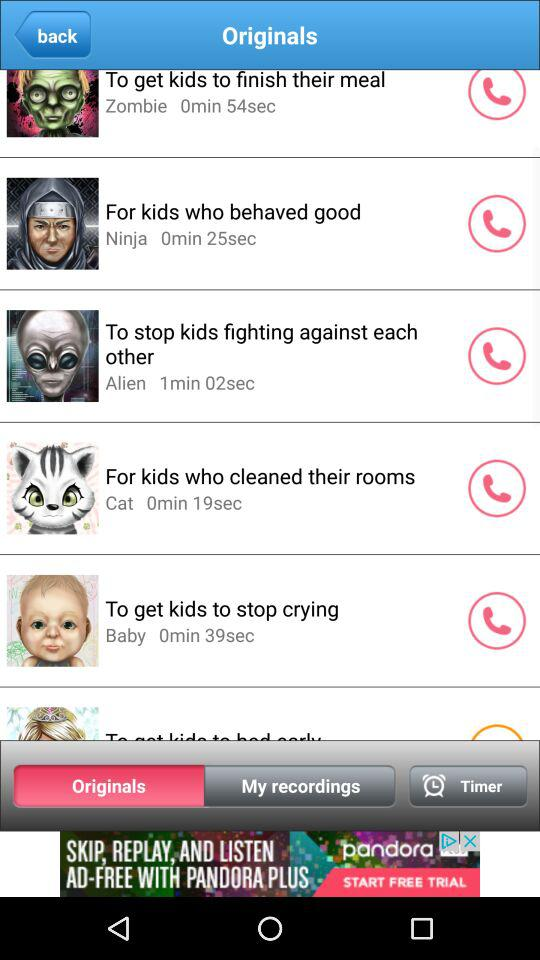What is the duration of "For kids who cleaned their rooms"? The duration is 19 seconds. 